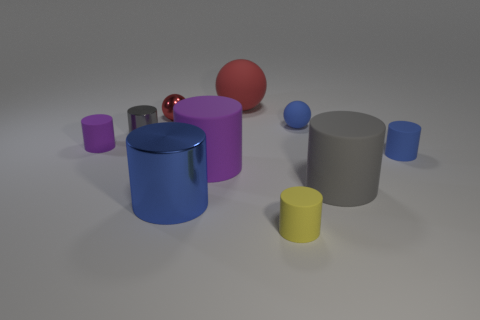What material is the blue ball that is the same size as the yellow cylinder?
Give a very brief answer. Rubber. What color is the large matte sphere?
Your answer should be very brief. Red. What is the material of the large cylinder that is both behind the big blue cylinder and to the left of the gray rubber thing?
Ensure brevity in your answer.  Rubber. Are there any blue rubber cylinders that are behind the purple matte thing that is on the left side of the big thing in front of the large gray rubber cylinder?
Your response must be concise. No. The other sphere that is the same color as the large matte sphere is what size?
Your answer should be compact. Small. Are there any tiny gray metal objects right of the small yellow rubber cylinder?
Ensure brevity in your answer.  No. What number of other objects are there of the same shape as the blue metal thing?
Give a very brief answer. 6. There is a shiny cylinder that is the same size as the blue matte cylinder; what is its color?
Offer a terse response. Gray. Are there fewer yellow cylinders that are to the left of the tiny yellow rubber thing than small blue balls left of the small shiny sphere?
Ensure brevity in your answer.  No. How many small objects are in front of the big gray matte cylinder that is right of the big blue thing that is in front of the small red metallic thing?
Provide a succinct answer. 1. 